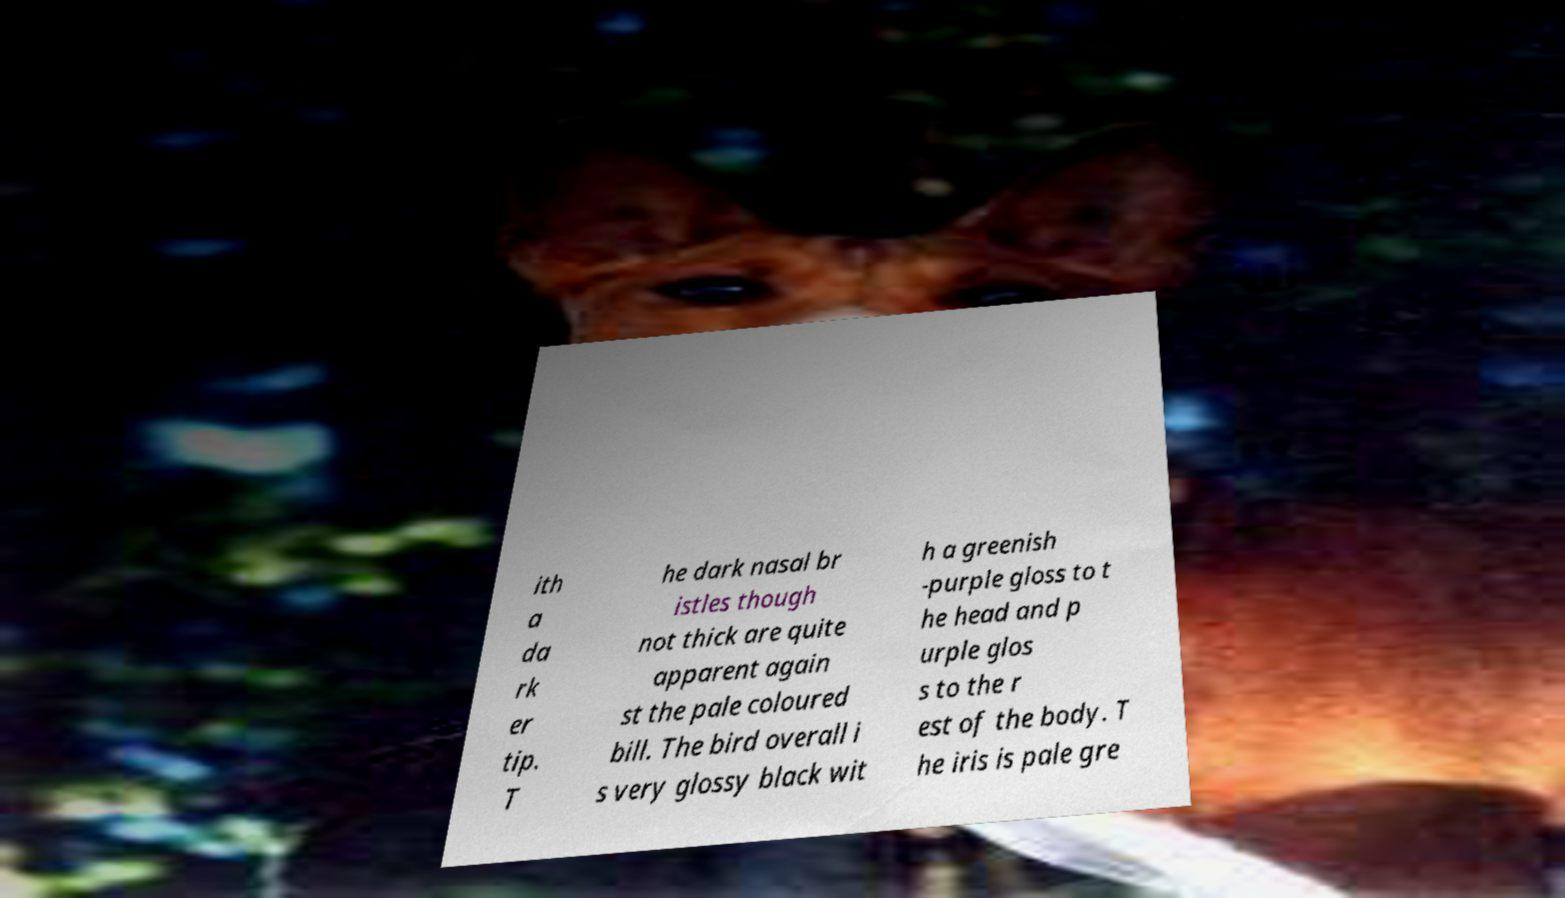For documentation purposes, I need the text within this image transcribed. Could you provide that? ith a da rk er tip. T he dark nasal br istles though not thick are quite apparent again st the pale coloured bill. The bird overall i s very glossy black wit h a greenish -purple gloss to t he head and p urple glos s to the r est of the body. T he iris is pale gre 